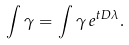<formula> <loc_0><loc_0><loc_500><loc_500>\int \gamma = \int \gamma \, e ^ { t D \lambda } .</formula> 